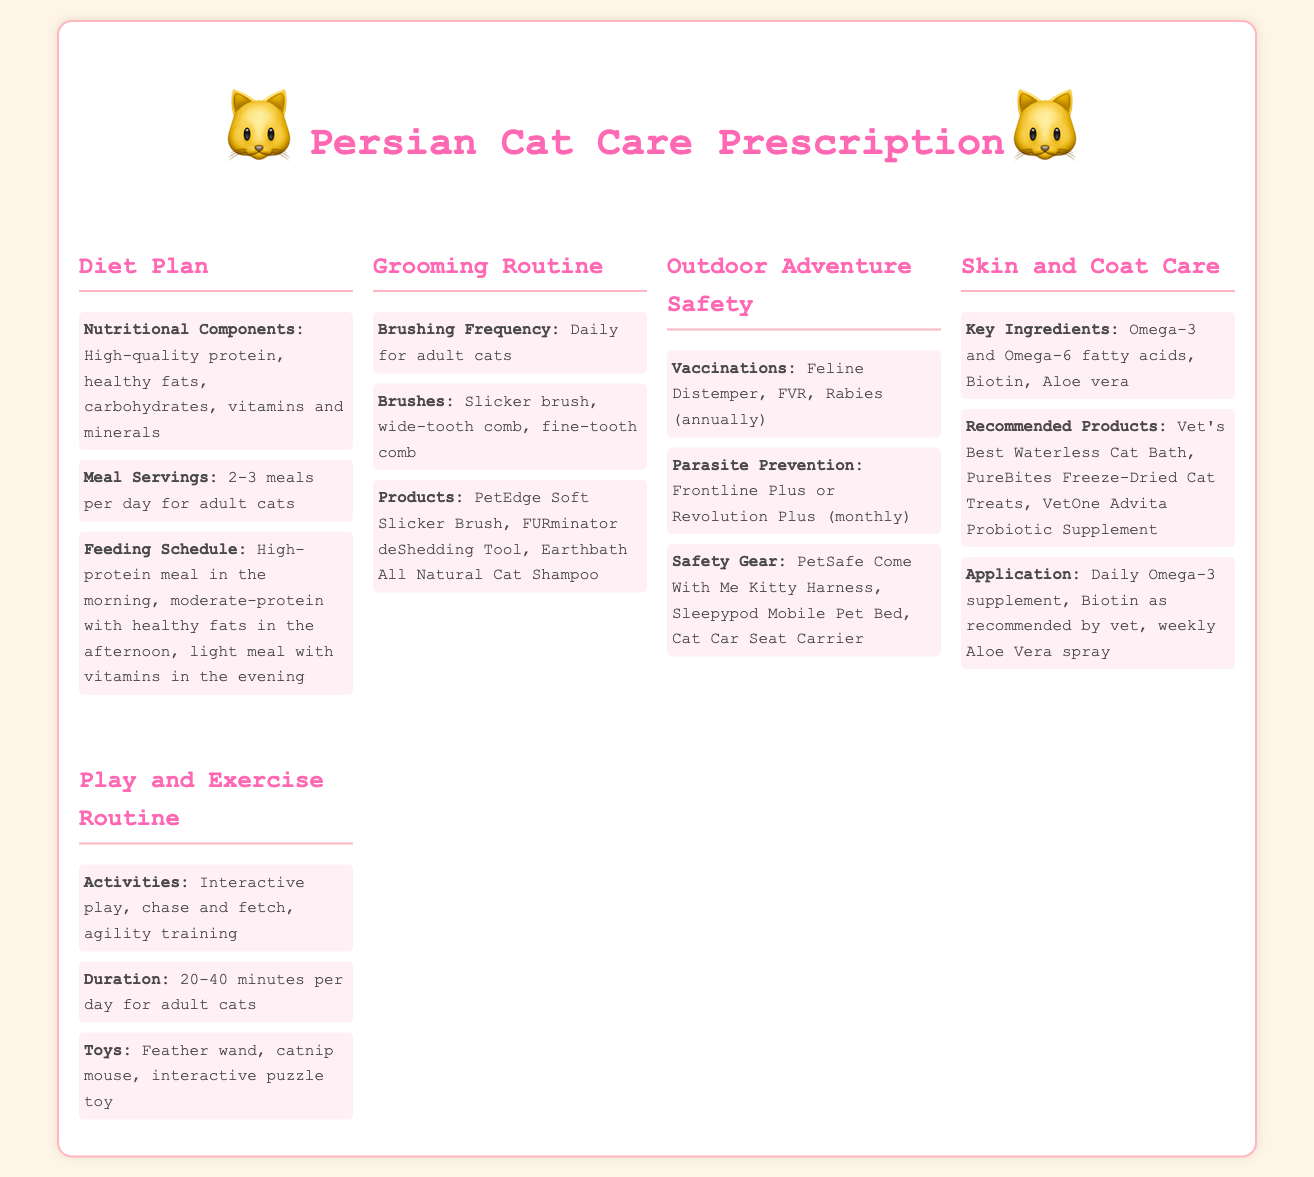what are the recommended nutritional components for a Persian cat's diet? The document lists high-quality protein, healthy fats, carbohydrates, vitamins and minerals as the recommended nutritional components.
Answer: high-quality protein, healthy fats, carbohydrates, vitamins and minerals how often should a Persian cat be brushed? The document specifies that a Persian cat should be brushed daily for adult cats.
Answer: daily what is the recommended frequency for vaccinations for outdoor safety? The document states that vaccinations should be administered annually for outdoor safety.
Answer: annually name one type of toy included in the play and exercise routine. The document mentions feather wand as one of the types of toys recommended for play and exercise.
Answer: feather wand which product is recommended for skin and coat care? The document recommends Vet's Best Waterless Cat Bath for skin and coat care.
Answer: Vet's Best Waterless Cat Bath how many meals should an adult Persian cat have daily? The document recommends that an adult Persian cat should have 2-3 meals per day.
Answer: 2-3 meals what is the duration of play suggested per day for a Persian cat? The document suggests a duration of 20-40 minutes per day for play and exercise.
Answer: 20-40 minutes what is the purpose of using a harness during outdoor adventures? The document includes a safety gear section, indicating that the harness is used for safety during outdoor adventures.
Answer: safety 